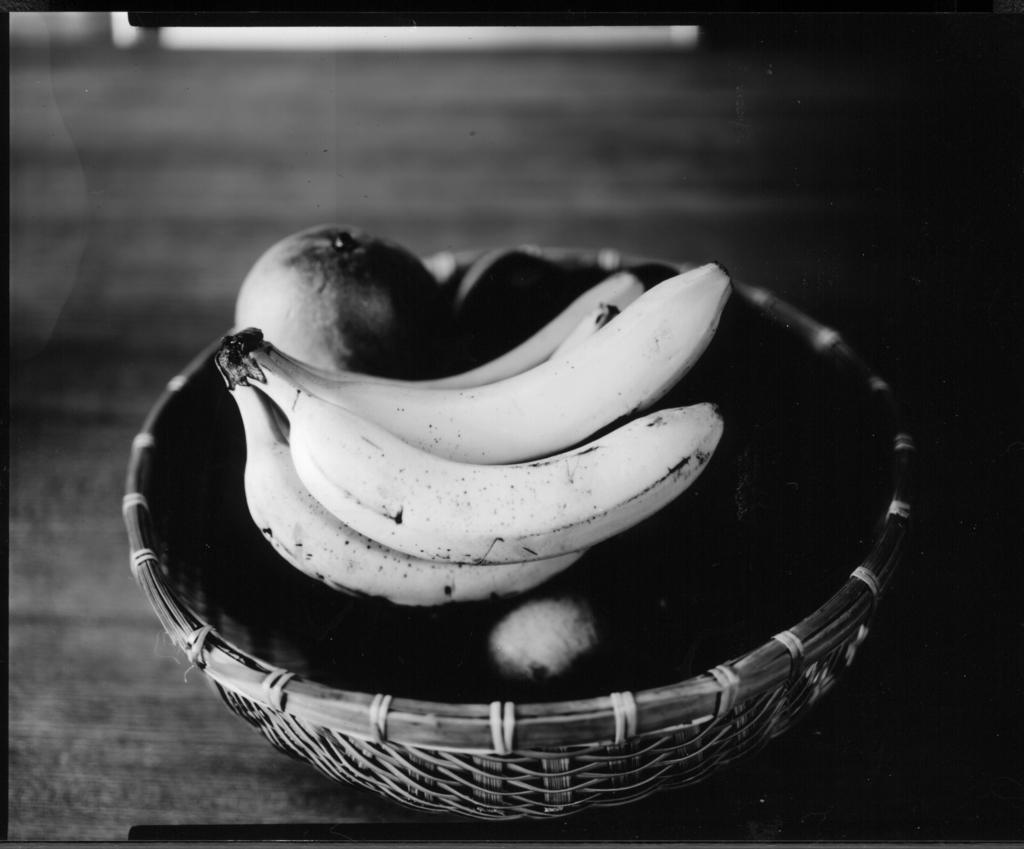What is the color scheme of the image? The image is black and white. What object can be seen in the image? There is a basket in the image. What is inside the basket? Bananas and other fruits are present in the basket. Can you describe the background of the image? The background of the image is blurry. How many sticks are being used to swing in the image? There are no sticks or swings present in the image. What type of respect is being shown in the image? There is no indication of respect being shown in the image, as it primarily features a basket with fruits. 